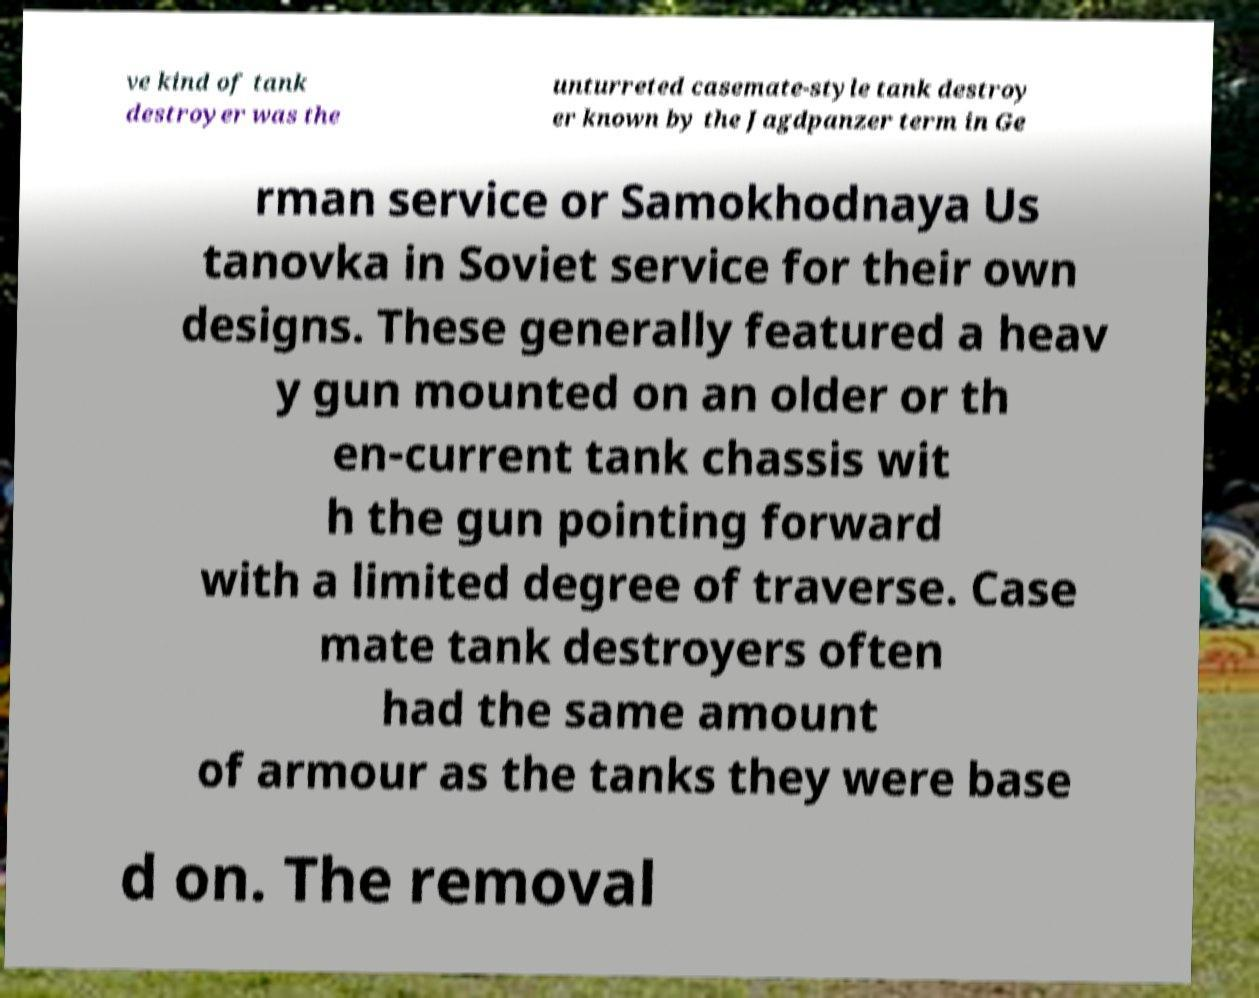There's text embedded in this image that I need extracted. Can you transcribe it verbatim? ve kind of tank destroyer was the unturreted casemate-style tank destroy er known by the Jagdpanzer term in Ge rman service or Samokhodnaya Us tanovka in Soviet service for their own designs. These generally featured a heav y gun mounted on an older or th en-current tank chassis wit h the gun pointing forward with a limited degree of traverse. Case mate tank destroyers often had the same amount of armour as the tanks they were base d on. The removal 